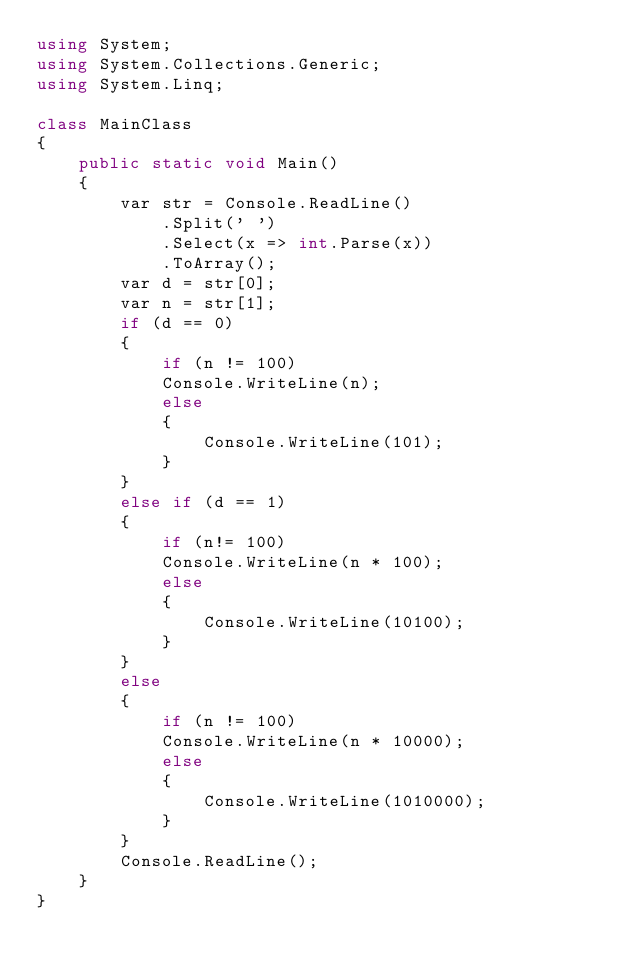Convert code to text. <code><loc_0><loc_0><loc_500><loc_500><_C#_>using System;
using System.Collections.Generic;
using System.Linq;
 
class MainClass
{
    public static void Main()
    {
        var str = Console.ReadLine()
            .Split(' ')
            .Select(x => int.Parse(x))
            .ToArray();
        var d = str[0];
        var n = str[1];
        if (d == 0)
        {
            if (n != 100)
            Console.WriteLine(n);
            else
            {
                Console.WriteLine(101);
            }
        }
        else if (d == 1)
        {
            if (n!= 100)
            Console.WriteLine(n * 100);
            else
            {
                Console.WriteLine(10100);
            }
        }
        else
        {
            if (n != 100)
            Console.WriteLine(n * 10000);
            else
            {
                Console.WriteLine(1010000);
            }
        }
        Console.ReadLine();
    }
}   </code> 